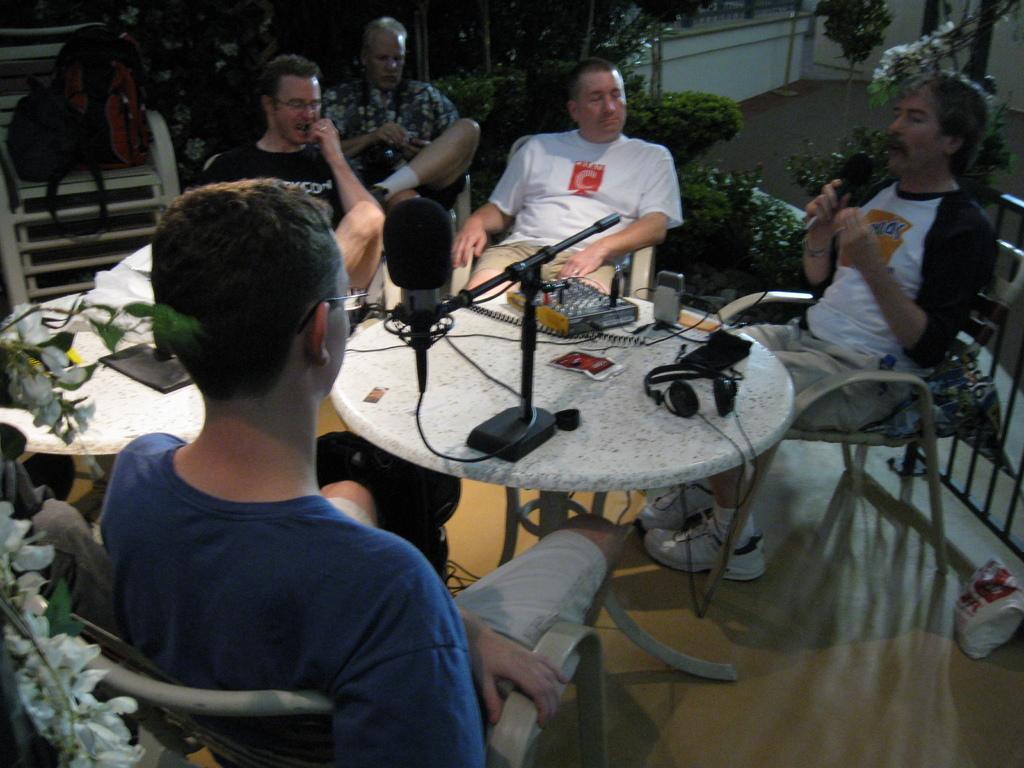Can you describe this image briefly? In this image I see 5 men who are sitting on chairs and this man is holding a mic in his hand, I can also see there are tables on which there is a microphone, a headphone and and other things on it. In the background I see the plants and bags on this chair. 